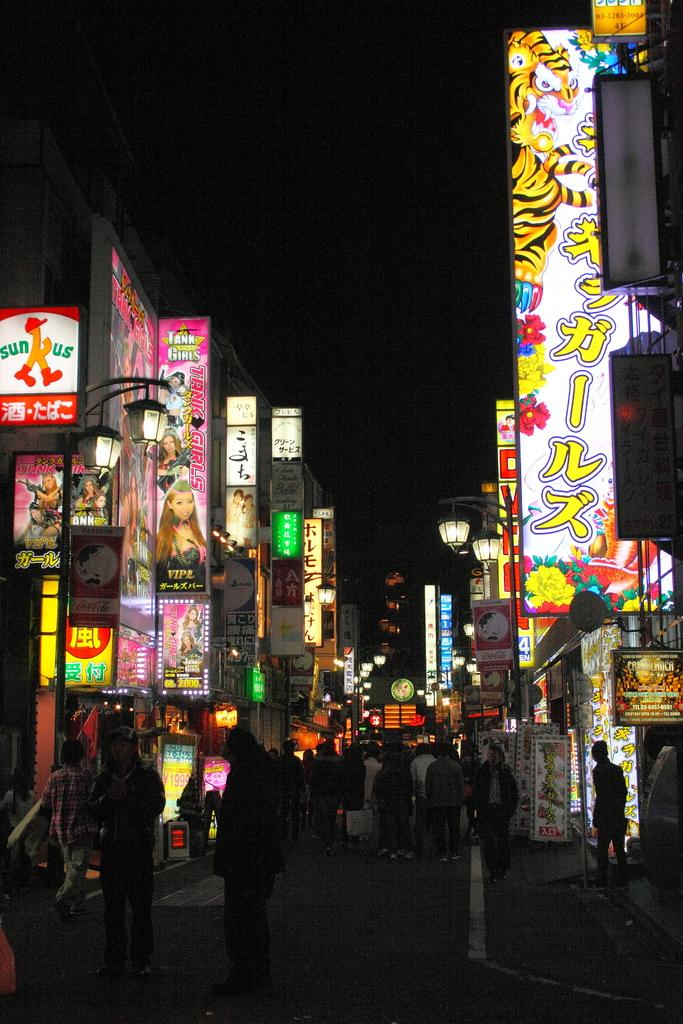What are the people in the image doing? The people in the image are standing on the road. What can be seen on both sides of the road? There are buildings on both sides of the road. What is on the buildings in the image? The buildings have hoardings. What is visible at the top of the image? The sky is visible at the top of the image. What type of ring can be seen on the finger of the person in the image? There is no person wearing a ring in the image. What type of love is being expressed by the people in the image? There is no indication of love being expressed in the image, as the people are simply standing on the road. 